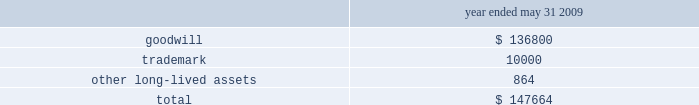The following details the impairment charge resulting from our review ( in thousands ) : .
Net income attributable to noncontrolling interests , net of tax noncontrolling interest , net of tax increased $ 28.9 million from $ 8.1 million fiscal 2008 .
The increase was primarily related to our acquisition of a 51% ( 51 % ) majority interest in hsbc merchant services , llp on june 30 , net income attributable to global payments and diluted earnings per share during fiscal 2009 we reported net income of $ 37.2 million ( $ 0.46 diluted earnings per share ) .
Liquidity and capital resources a significant portion of our liquidity comes from operating cash flows , which are generally sufficient to fund operations , planned capital expenditures , debt service and various strategic investments in our business .
Cash flow from operations is used to make planned capital investments in our business , to pursue acquisitions that meet our corporate objectives , to pay dividends , and to pay off debt and repurchase our shares at the discretion of our board of directors .
Accumulated cash balances are invested in high-quality and marketable short term instruments .
Our capital plan objectives are to support the company 2019s operational needs and strategic plan for long term growth while maintaining a low cost of capital .
Lines of credit are used in certain of our markets to fund settlement and as a source of working capital and , along with other bank financing , to fund acquisitions .
We regularly evaluate our liquidity and capital position relative to cash requirements , and we may elect to raise additional funds in the future , either through the issuance of debt , equity or otherwise .
At may 31 , 2010 , we had cash and cash equivalents totaling $ 769.9 million .
Of this amount , we consider $ 268.1 million to be available cash , which generally excludes settlement related and merchant reserve cash balances .
Settlement related cash balances represent surplus funds that we hold on behalf of our member sponsors when the incoming amount from the card networks precedes the member sponsors 2019 funding obligation to the merchant .
Merchant reserve cash balances represent funds collected from our merchants that serve as collateral ( 201cmerchant reserves 201d ) to minimize contingent liabilities associated with any losses that may occur under the merchant agreement .
At may 31 , 2010 , our cash and cash equivalents included $ 199.4 million related to merchant reserves .
While this cash is not restricted in its use , we believe that designating this cash to collateralize merchant reserves strengthens our fiduciary standing with our member sponsors and is in accordance with the guidelines set by the card networks .
See cash and cash equivalents and settlement processing assets and obligations under note 1 in the notes to the consolidated financial statements for additional details .
Net cash provided by operating activities increased $ 82.8 million to $ 465.8 million for fiscal 2010 from the prior year .
Income from continuing operations increased $ 16.0 million and we had cash provided by changes in working capital of $ 60.2 million .
The working capital change was primarily due to the change in net settlement processing assets and obligations of $ 80.3 million and the change in accounts receivable of $ 13.4 million , partially offset by the change .
What was the percentage that net income attributable to noncontrolling interests , net of tax noncontrolling interest , net of tax increased from 2008 to 2009? 
Rationale: to find the answer one must subtract the totals of the two years and then take that answer and divide it by the total for 2008 .
Computations: ((28.9 - 8.1) / 8.1)
Answer: 2.5679. 